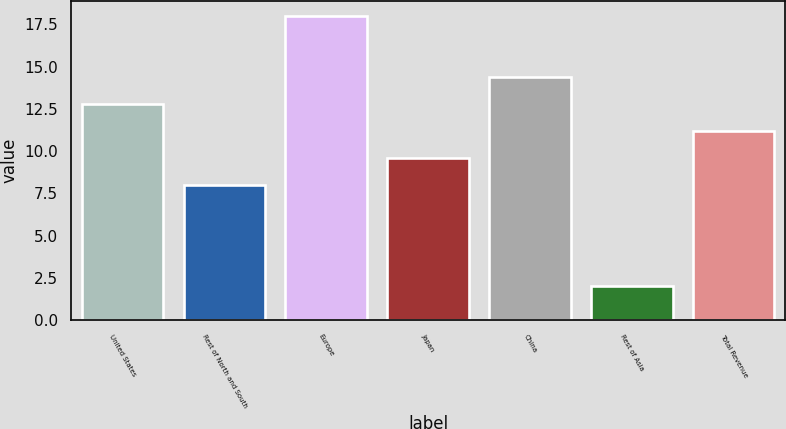Convert chart to OTSL. <chart><loc_0><loc_0><loc_500><loc_500><bar_chart><fcel>United States<fcel>Rest of North and South<fcel>Europe<fcel>Japan<fcel>China<fcel>Rest of Asia<fcel>Total Revenue<nl><fcel>12.8<fcel>8<fcel>18<fcel>9.6<fcel>14.4<fcel>2<fcel>11.2<nl></chart> 